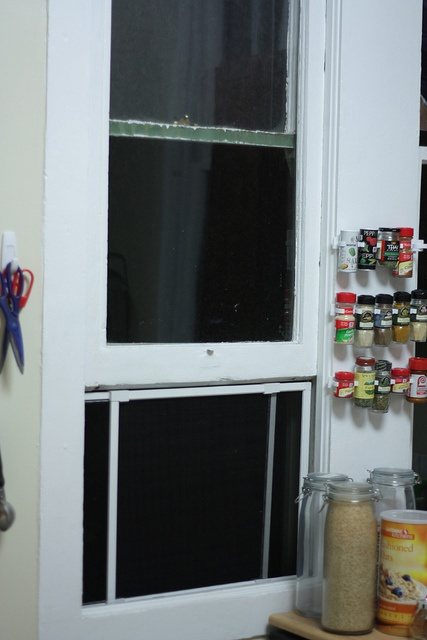Describe the objects in this image and their specific colors. I can see bottle in lightgray and gray tones, bottle in lightgray, gray, black, and darkgray tones, scissors in lightgray, navy, black, gray, and maroon tones, bottle in lightgray, gray, and darkgray tones, and bottle in lightgray, olive, gray, maroon, and darkgreen tones in this image. 